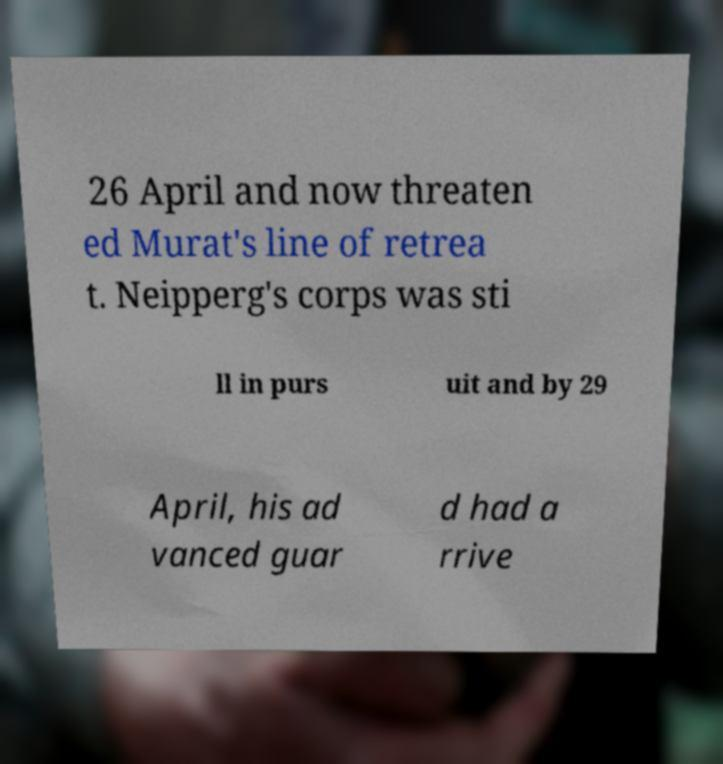Please identify and transcribe the text found in this image. 26 April and now threaten ed Murat's line of retrea t. Neipperg's corps was sti ll in purs uit and by 29 April, his ad vanced guar d had a rrive 